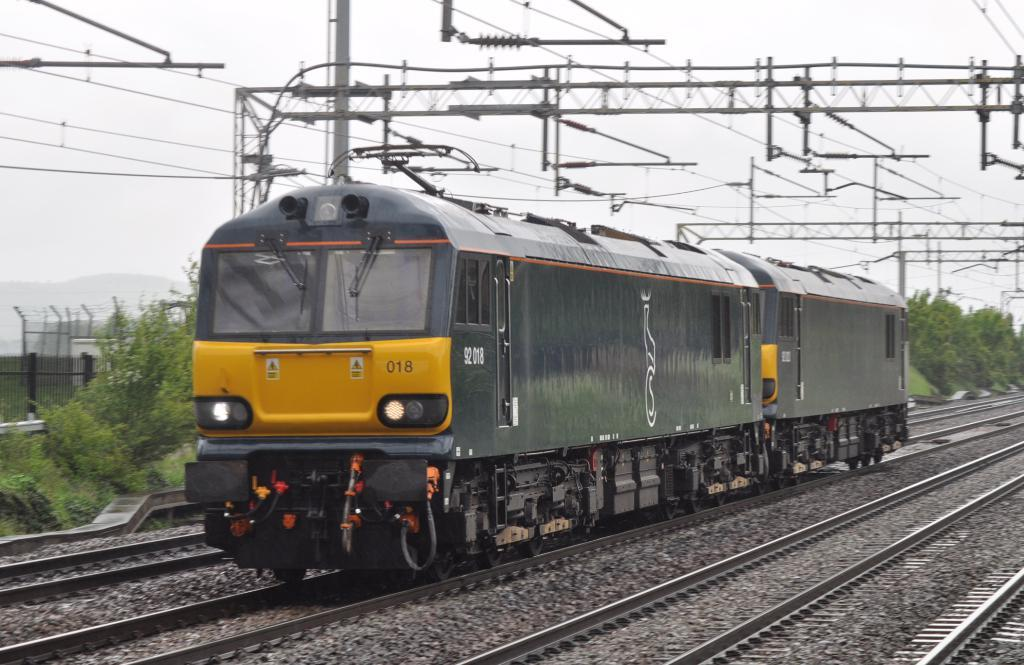<image>
Render a clear and concise summary of the photo. a train with the number 92 on it 